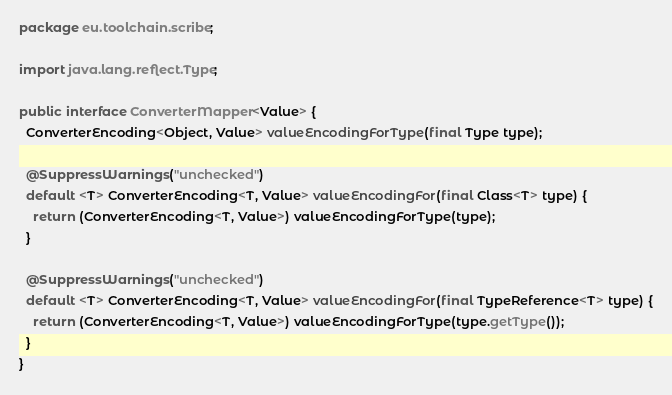<code> <loc_0><loc_0><loc_500><loc_500><_Java_>package eu.toolchain.scribe;

import java.lang.reflect.Type;

public interface ConverterMapper<Value> {
  ConverterEncoding<Object, Value> valueEncodingForType(final Type type);

  @SuppressWarnings("unchecked")
  default <T> ConverterEncoding<T, Value> valueEncodingFor(final Class<T> type) {
    return (ConverterEncoding<T, Value>) valueEncodingForType(type);
  }

  @SuppressWarnings("unchecked")
  default <T> ConverterEncoding<T, Value> valueEncodingFor(final TypeReference<T> type) {
    return (ConverterEncoding<T, Value>) valueEncodingForType(type.getType());
  }
}
</code> 